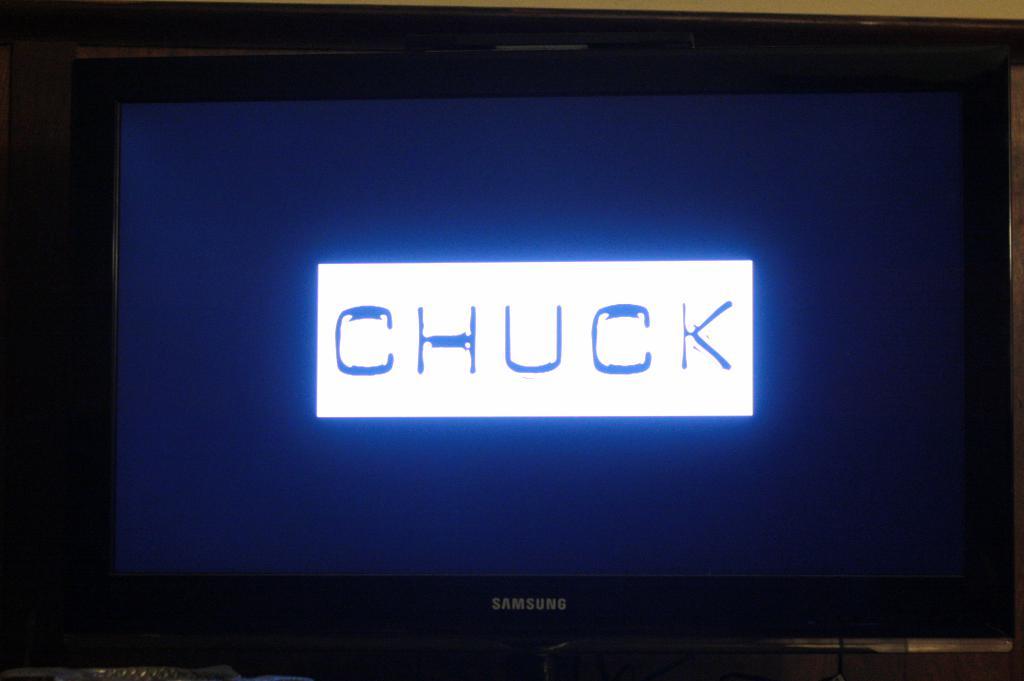What is the brand of the tv?
Your answer should be compact. Samsung. What does it say on the tv?
Ensure brevity in your answer.  Chuck. 